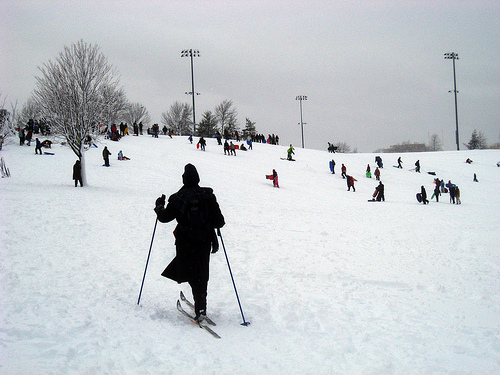Please provide the bounding box coordinate of the region this sentence describes: Skier wearing black wool cap on head. [0.36, 0.45, 0.41, 0.5] accurately bounds the region describing the skier with a black wool cap. 